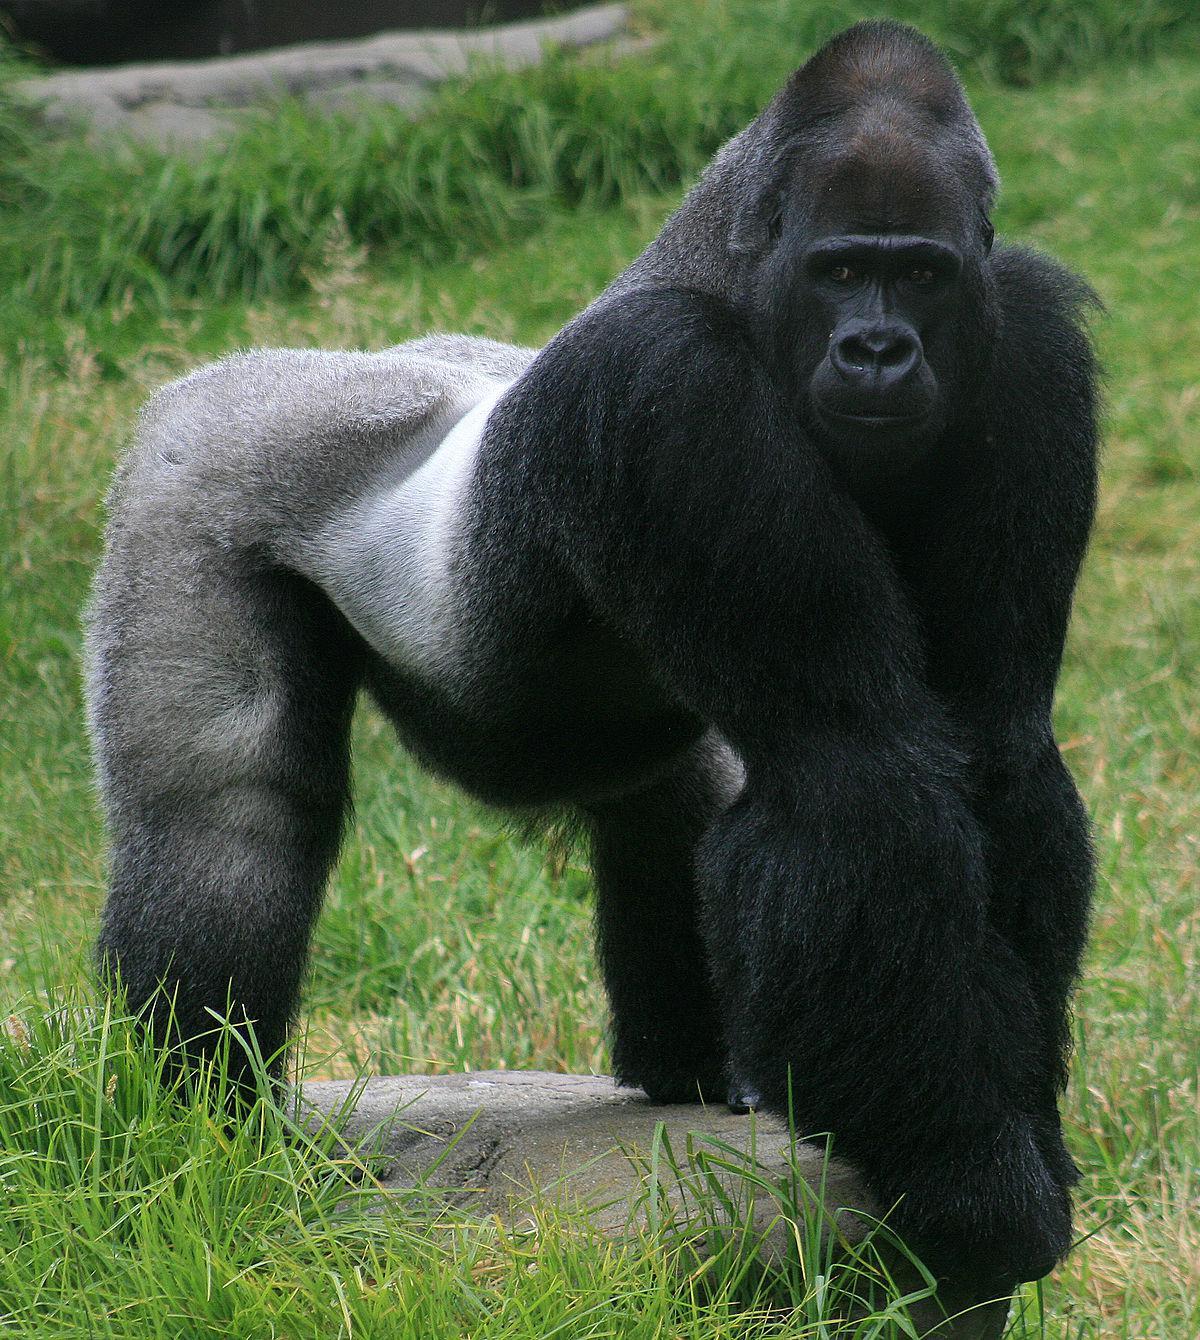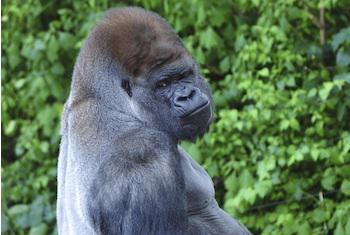The first image is the image on the left, the second image is the image on the right. Considering the images on both sides, is "A gorilla is on all fours, but without bared teeth." valid? Answer yes or no. Yes. 